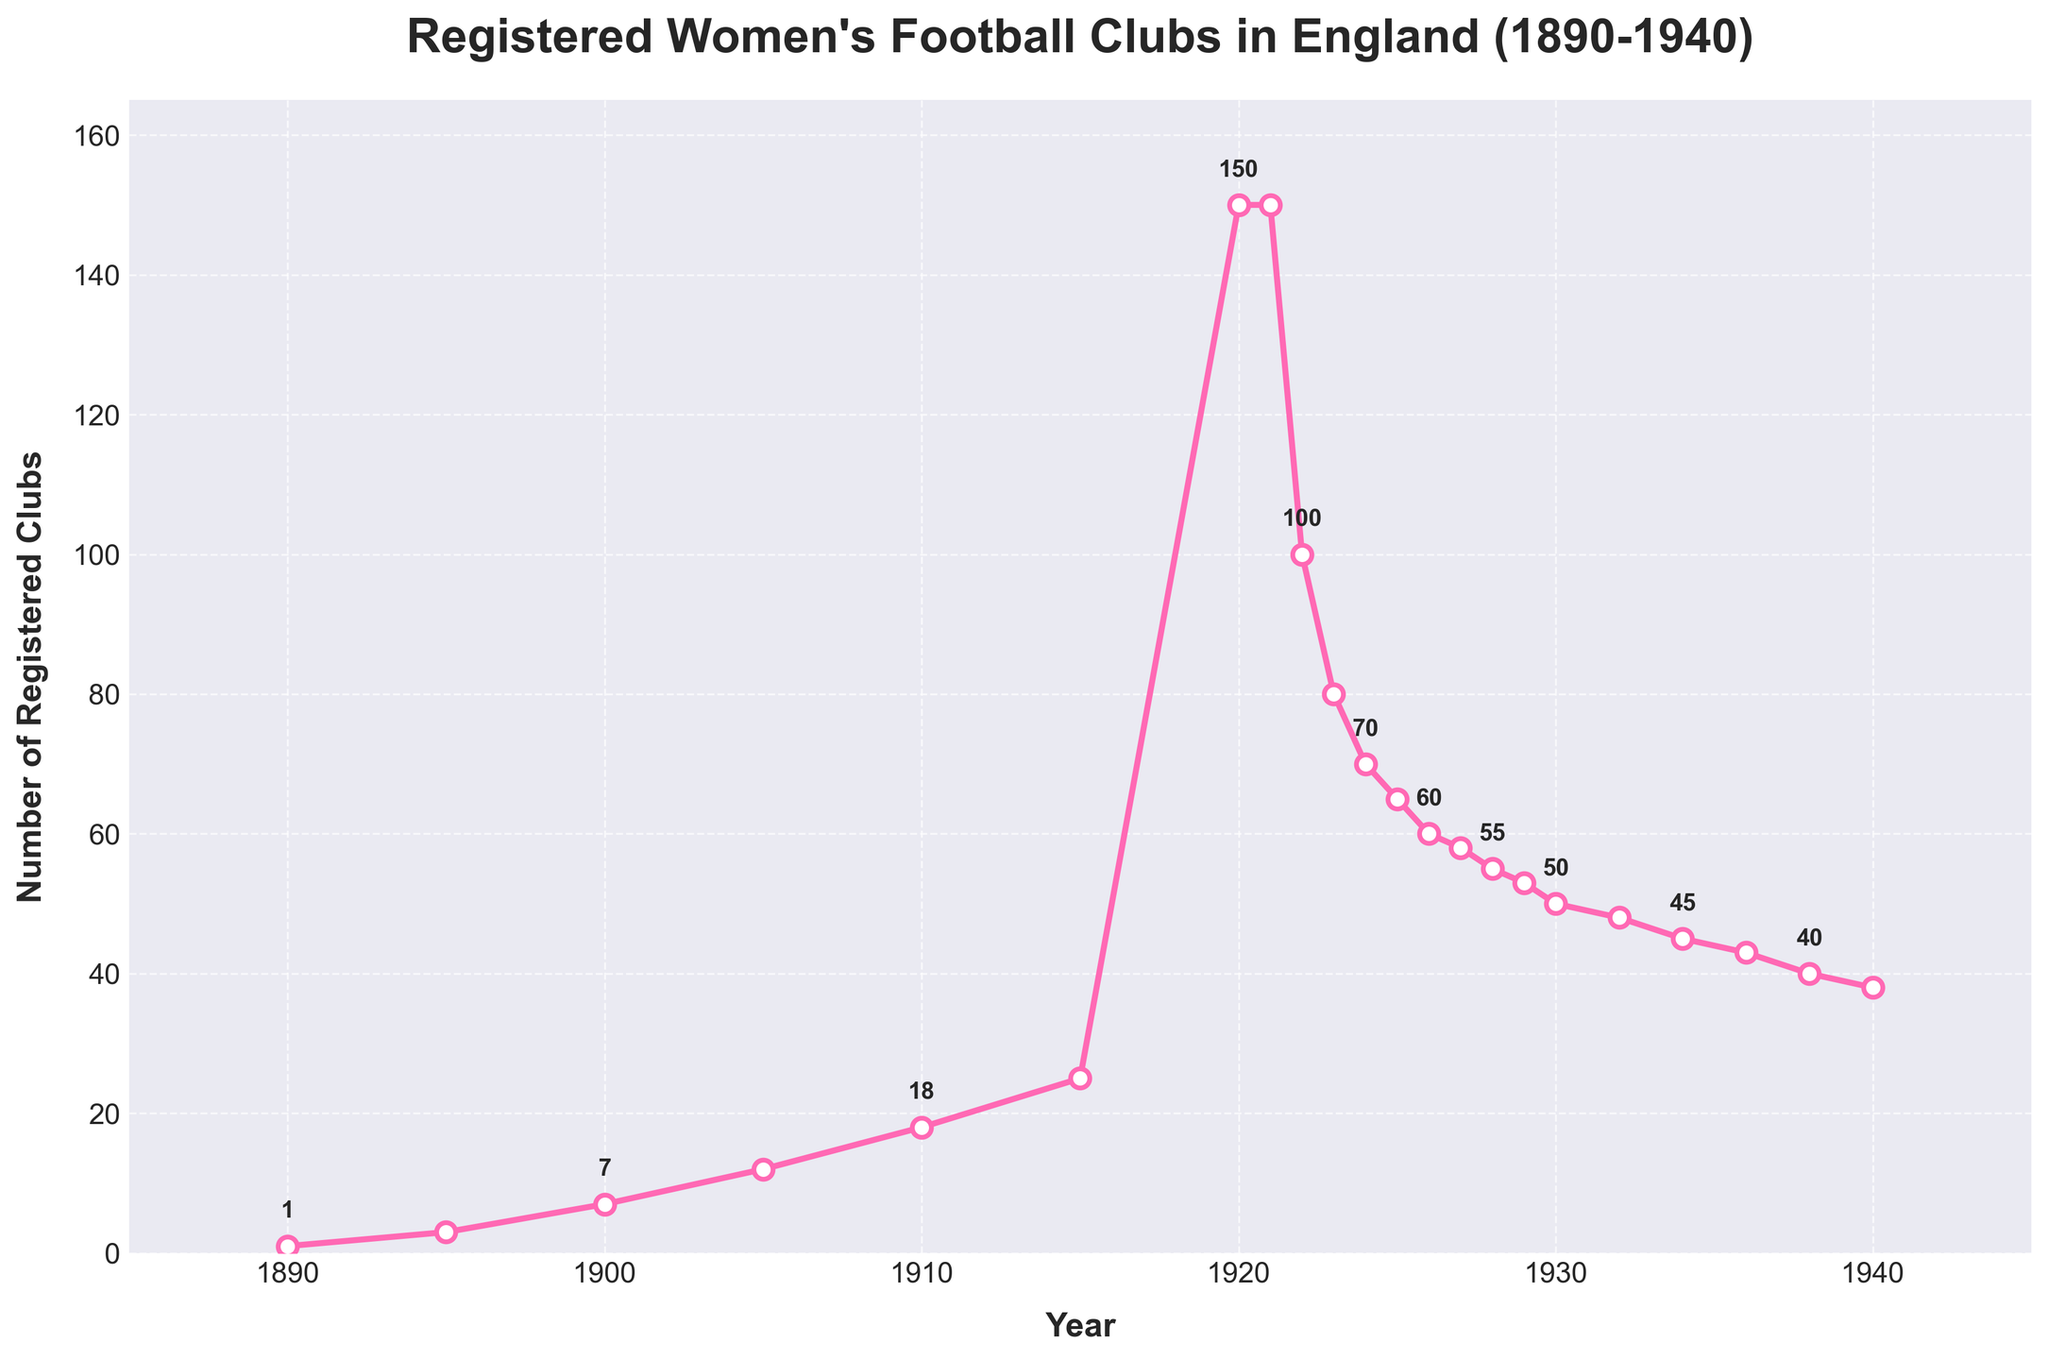How many registered women's football clubs were there in England in 1910? Look at the data point corresponding to the year 1910 in the figure.
Answer: 18 In which year did the number of registered clubs reach its peak, and what was the number? Identify the highest point in the line chart, which corresponds to the peak number of clubs and the respective year on the x-axis.
Answer: 1920, 150 What is the difference in the number of registered clubs between 1920 and 1922? Find the number of clubs in 1920 and 1922 and calculate the difference: 150 (1920) - 100 (1922).
Answer: 50 By how much did the number of registered clubs increase from 1890 to 1915? Subtract the number of clubs in 1890 from the number in 1915: 25 (1915) - 1 (1890).
Answer: 24 Between which years did the number of registered women's football clubs experience the most significant drop, and what was the magnitude of this drop? Compare the drops between consecutive years; the largest drop is between 1921 and 1922, from 150 to 100, a magnitude of 50.
Answer: 1921 and 1922, 50 How did the number of clubs change from 1930 to 1932? Identify the values for 1930 and 1932; subtract the number in 1932 from 1930: 50 (1930) - 48 (1932).
Answer: Decreased by 2 Which year shows a steady decline starting from 1922 through 1940? Observe the general trend after 1922 to the end of the timeline; the decline begins in 1922 and continues consistently.
Answer: 1922 What was the average number of registered clubs per year from 1890 to 1910? Add the number of clubs for the years 1890, 1895, 1900, 1905, and 1910, then divide by the number of data points: (1 + 3 + 7 + 12 + 18) / 5.
Answer: 8.2 What visual indications are given to emphasize the values of specific data points? The points are marked with white-filled circles outlined in pink, and every other data point is annotated with its value.
Answer: White-filled circles with pink outlines; annotations How did the number of clubs change during the 1920s? Review the data from 1920 to 1929; it starts at 150, drops significantly by 1922, and then declines gradually towards the end of the decade.
Answer: Initial rise, sharp drop, then gradual decline 